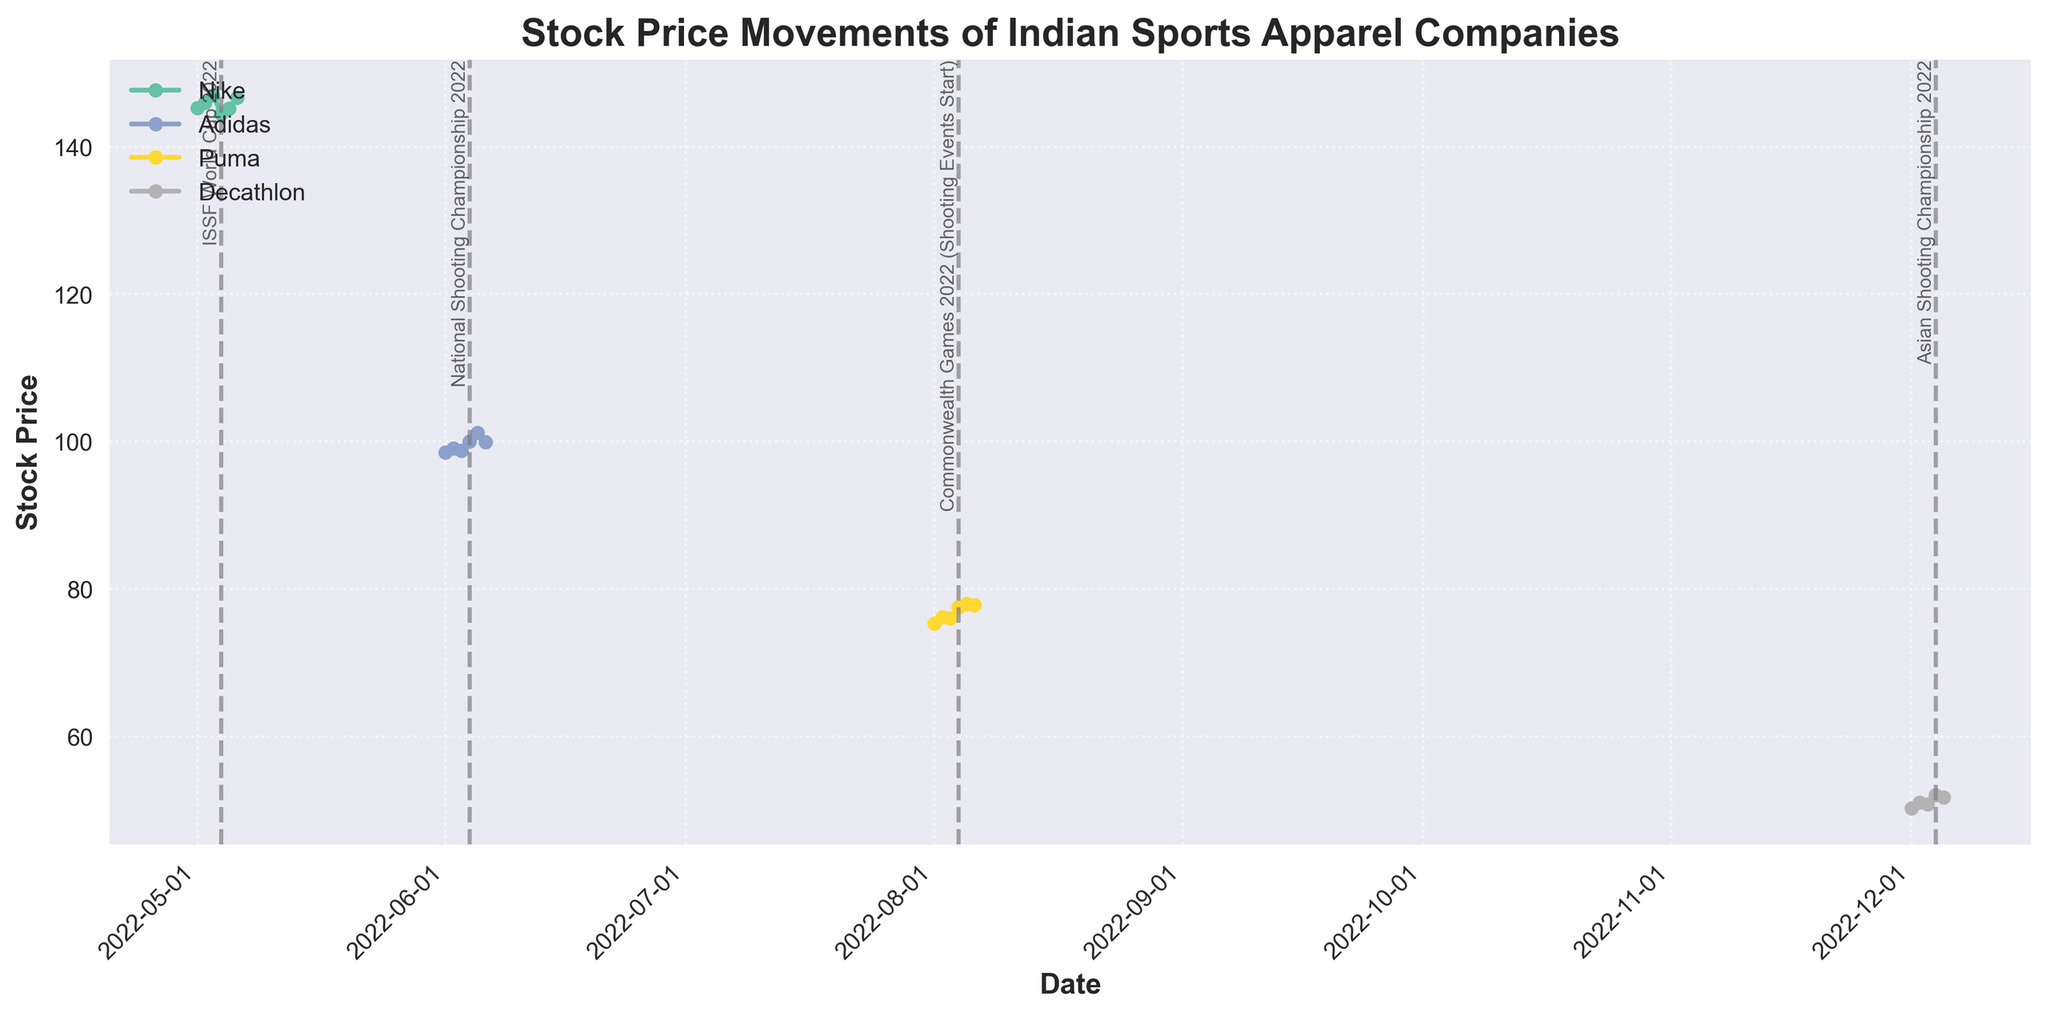What's the stock price of Nike on May 4th, 2022? The figure marks specific dates and stock prices for Nike. On May 4th, 2022, the stock price is shown as 144.50.
Answer: 144.50 Which company's stock price has the highest value on its event day? Each company's event date and respective stock prices are shown: Nike on May 4th with 144.50, Adidas on June 4th with 100.00, Puma on August 4th with 77.50, and Decathlon on December 4th with 52.00. Nike has the highest stock price of 144.50.
Answer: Nike How did the stock price of Adidas change over the period from June 1st, 2022, to June 6th, 2022? By observing the data points from June 1st to June 6th for Adidas, the stock prices are 98.50, 99.10, 98.80, 100.00, 101.20, and 99.90. This shows an overall upward trend with a small dip on the last day.
Answer: Increased with minor fluctuation Identify the event with the largest stock price increase the next day, and state the companies and values involved. Comparing stock price differences the day after each event: Nike increases from 144.50 to 145.20, Adidas from 100.00 to 101.20, Puma from 77.50 to 78.00, and Decathlon decreases from 52.00 to 51.70. Adidas has the largest increase (1.20).
Answer: National Shooting Championship 2022; Adidas; 1.20 How did Puma's stock price change around the Commonwealth Games 2022 starting on August 4th, 2022? Before the event, Puma's stock prices are 75.30, 76.20, and 76.00. On the event start date, it is 77.50, and there is a rise to 78.00 on August 5th and a slight drop to 77.80 on August 6th.
Answer: Rose before the event, peaked during, and slightly dropped after Whose stock price had the least fluctuation during its event period? By calculating the maximum stock price change for each company on the event days and the surrounding days: 
- Nike's change: 144.50 -> 145.20 (0.70), 
- Adidas's change: 100.00 -> 101.20 (1.20), 
- Puma's change: 77.50 -> 77.80 (0.30), 
- Decathlon's change: 52.00 -> 51.70 (0.30). 
Puma and Decathlon fluctuate the least, both by 0.30.
Answer: Puma and Decathlon Which event occurs latest in the year and how does its stock price change pre- and post-event for the company involved? The latest event is the Asian Shooting Championship in December. Decathlon’s stock prices before the event are 50.20, 51.00, and 50.80. On event day, it is 52.00, and it falls to 51.70 post-event.
Answer: Asian Shooting Championship 2022; rose before the event, slightly fell after During which month does Nike see the most sudden drop in stock price and what are the values? By comparing Nike’s data in May, the highest drop occurs from May 3rd (147.00) to May 4th (144.50).
Answer: May; 147.00 to 144.50 